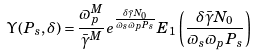Convert formula to latex. <formula><loc_0><loc_0><loc_500><loc_500>\Upsilon ( P _ { s } , \delta ) = \frac { \varpi _ { p } ^ { M } } { \bar { \gamma } ^ { M } } e ^ { \frac { \delta \bar { \gamma } N _ { 0 } } { \varpi _ { s } \varpi _ { p } P _ { s } } } E _ { 1 } \left ( \frac { \delta \bar { \gamma } N _ { 0 } } { \varpi _ { s } \varpi _ { p } P _ { s } } \right )</formula> 